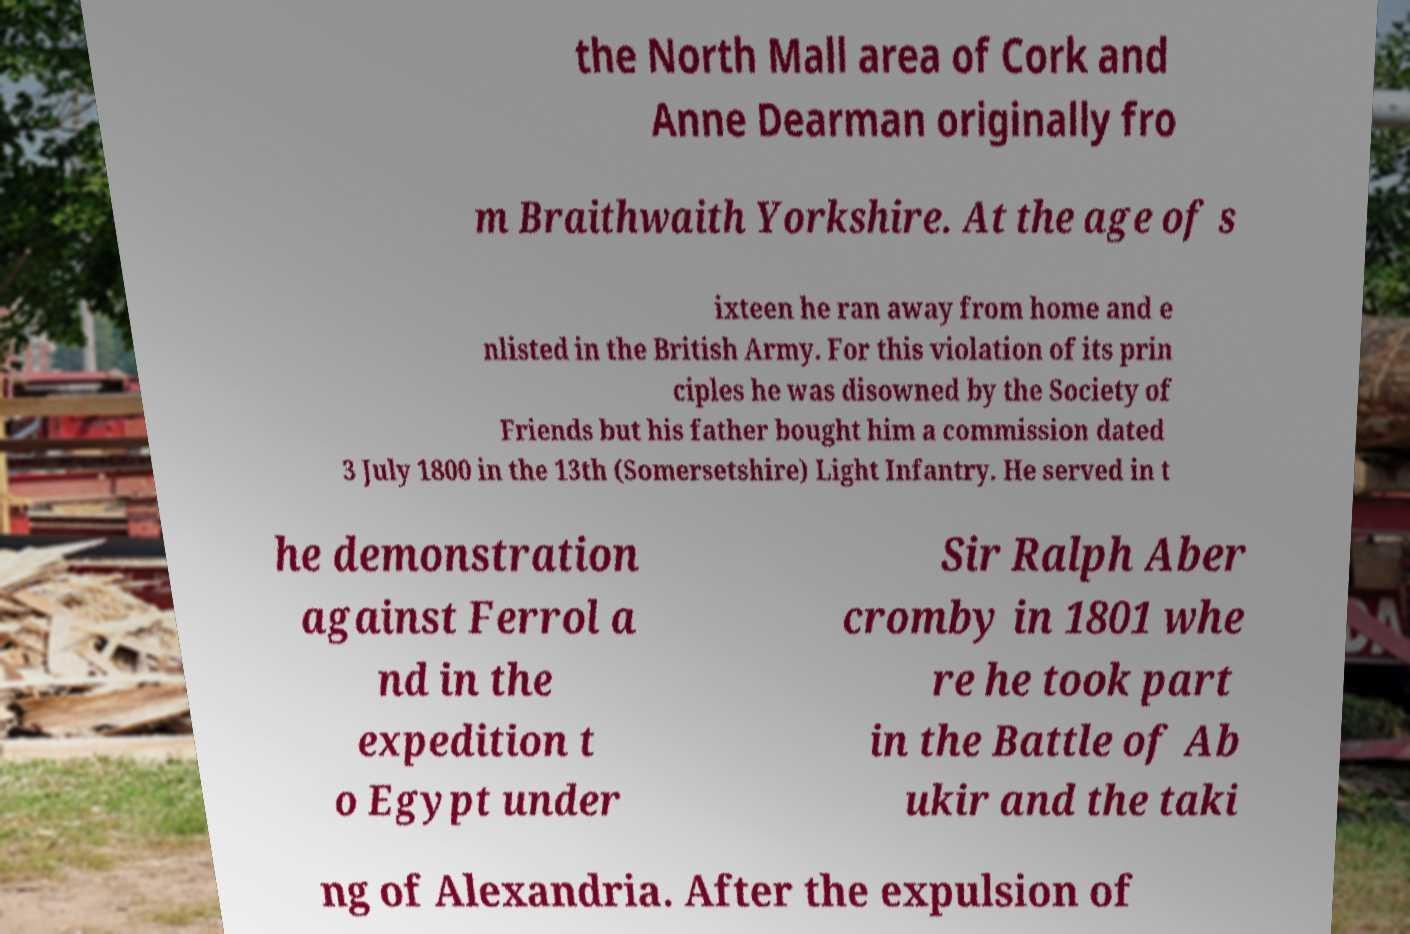Please identify and transcribe the text found in this image. the North Mall area of Cork and Anne Dearman originally fro m Braithwaith Yorkshire. At the age of s ixteen he ran away from home and e nlisted in the British Army. For this violation of its prin ciples he was disowned by the Society of Friends but his father bought him a commission dated 3 July 1800 in the 13th (Somersetshire) Light Infantry. He served in t he demonstration against Ferrol a nd in the expedition t o Egypt under Sir Ralph Aber cromby in 1801 whe re he took part in the Battle of Ab ukir and the taki ng of Alexandria. After the expulsion of 